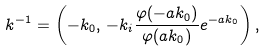Convert formula to latex. <formula><loc_0><loc_0><loc_500><loc_500>k ^ { - 1 } = \left ( - k _ { 0 } , \, - k _ { i } \frac { \varphi ( - a k _ { 0 } ) } { \varphi ( a k _ { 0 } ) } e ^ { - a k _ { 0 } } \right ) ,</formula> 